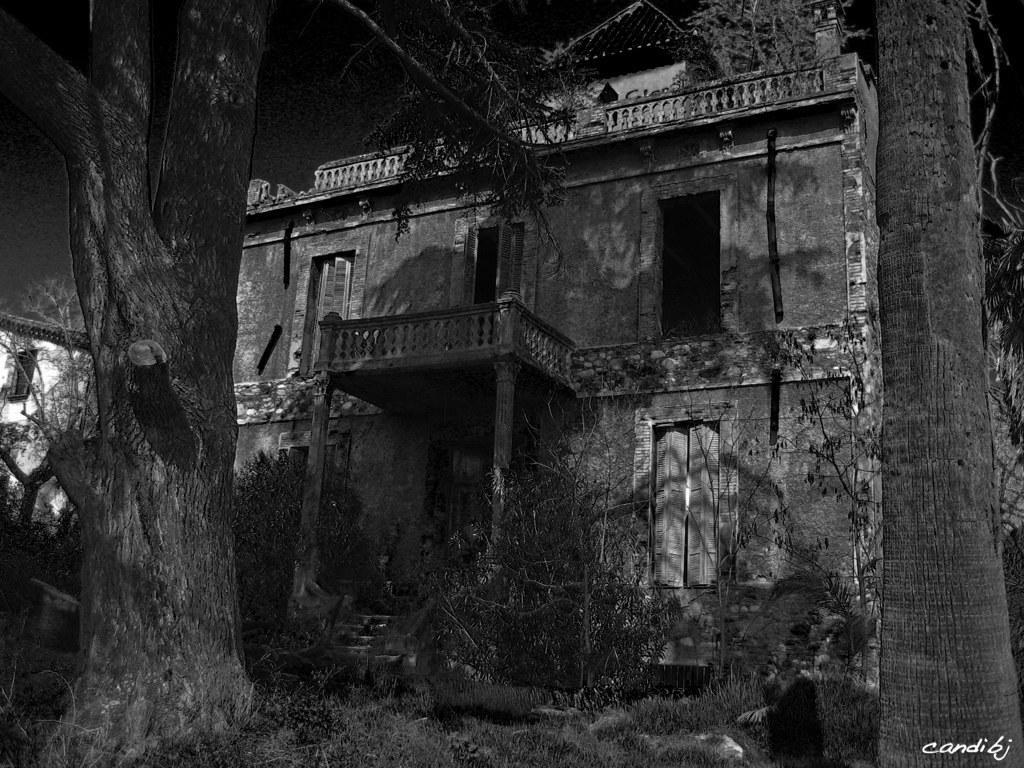Please provide a concise description of this image. In this image I can see a building, at left I can see few trees and the image is in black in color. 